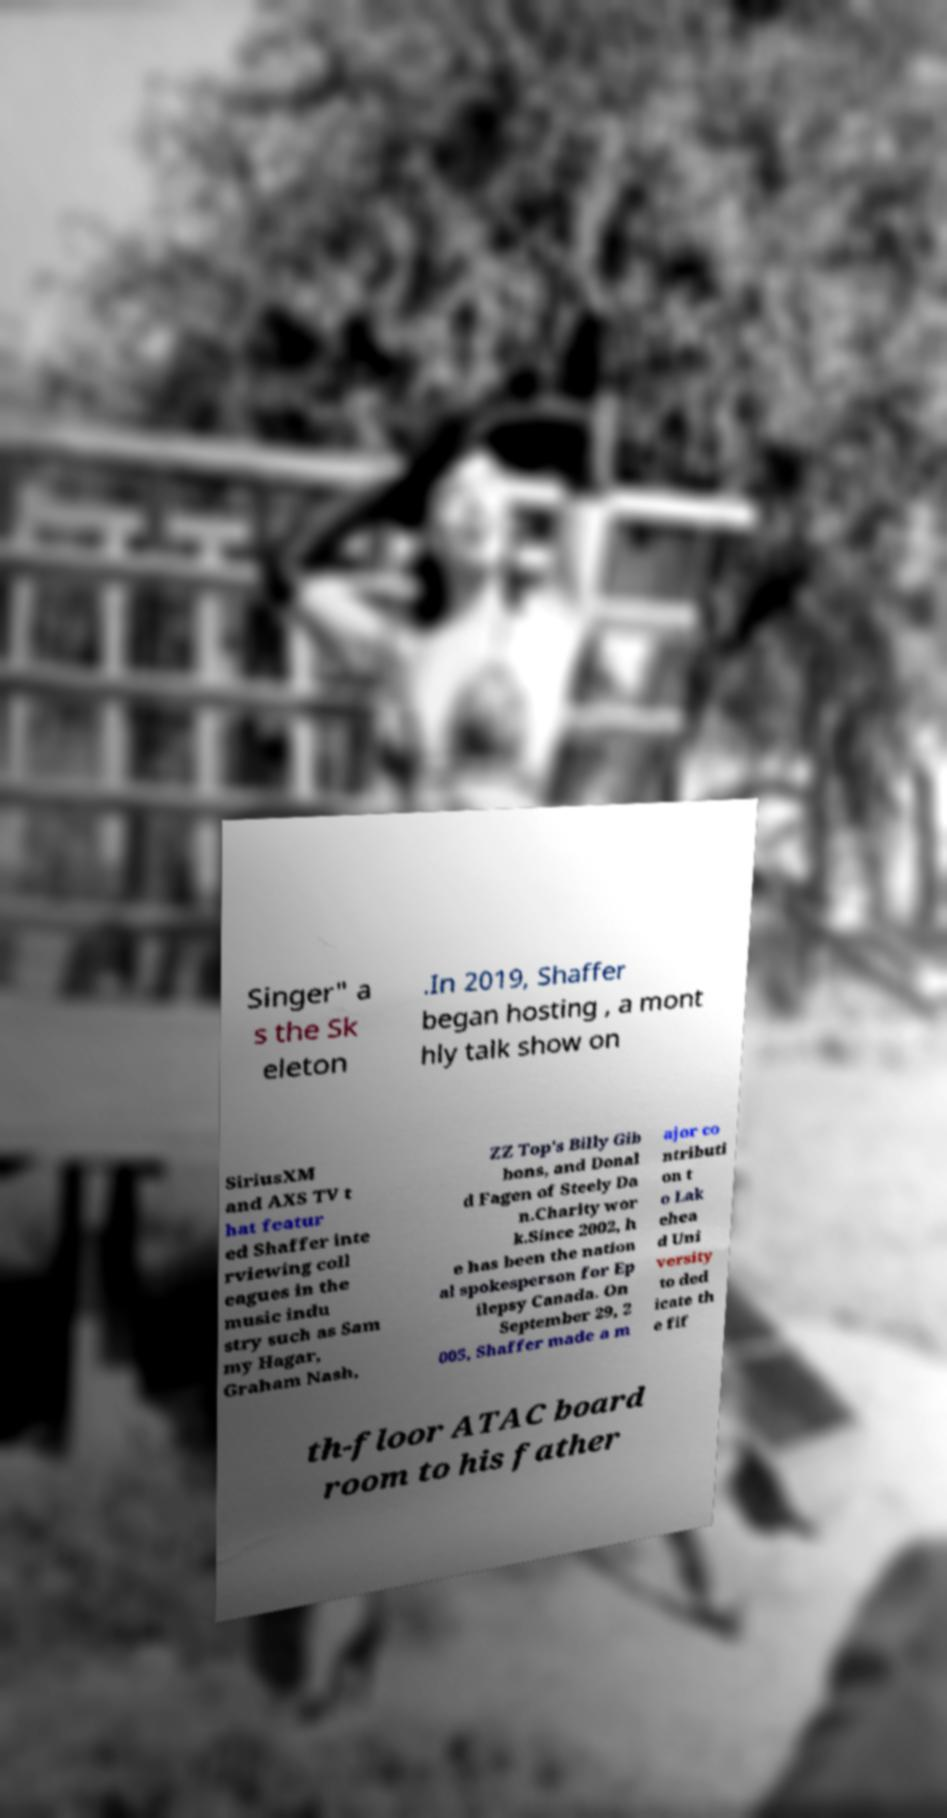I need the written content from this picture converted into text. Can you do that? Singer" a s the Sk eleton .In 2019, Shaffer began hosting , a mont hly talk show on SiriusXM and AXS TV t hat featur ed Shaffer inte rviewing coll eagues in the music indu stry such as Sam my Hagar, Graham Nash, ZZ Top's Billy Gib bons, and Donal d Fagen of Steely Da n.Charity wor k.Since 2002, h e has been the nation al spokesperson for Ep ilepsy Canada. On September 29, 2 005, Shaffer made a m ajor co ntributi on t o Lak ehea d Uni versity to ded icate th e fif th-floor ATAC board room to his father 